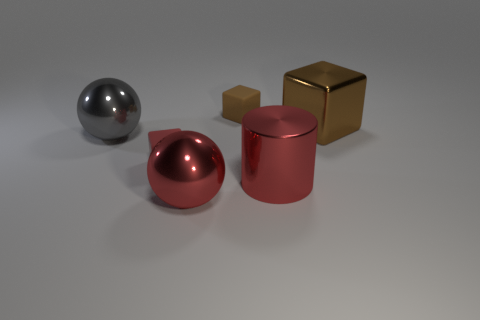There is a big gray shiny thing; are there any red shiny spheres on the left side of it?
Give a very brief answer. No. There is a brown object behind the large brown block; is its shape the same as the big red object that is to the left of the brown rubber block?
Offer a very short reply. No. What number of objects are either big metal cylinders or brown blocks that are left of the red cylinder?
Provide a short and direct response. 2. What number of other objects are the same shape as the brown rubber thing?
Provide a short and direct response. 2. Does the red object on the right side of the red shiny sphere have the same material as the tiny brown thing?
Keep it short and to the point. No. What number of objects are either metallic objects or tiny blocks?
Offer a terse response. 6. What is the size of the shiny thing that is the same shape as the small red rubber thing?
Keep it short and to the point. Large. What size is the red rubber thing?
Your response must be concise. Small. Is the number of blocks behind the tiny brown thing greater than the number of gray metal cubes?
Offer a very short reply. No. Is there anything else that is the same material as the red block?
Your response must be concise. Yes. 